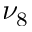Convert formula to latex. <formula><loc_0><loc_0><loc_500><loc_500>\nu _ { 8 }</formula> 